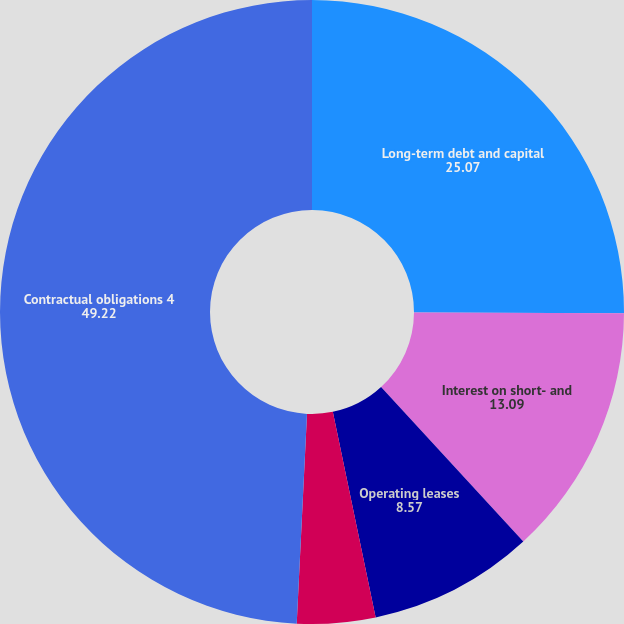<chart> <loc_0><loc_0><loc_500><loc_500><pie_chart><fcel>Long-term debt and capital<fcel>Interest on short- and<fcel>Operating leases<fcel>Purchase obligations 3<fcel>Contractual obligations 4<nl><fcel>25.07%<fcel>13.09%<fcel>8.57%<fcel>4.05%<fcel>49.22%<nl></chart> 